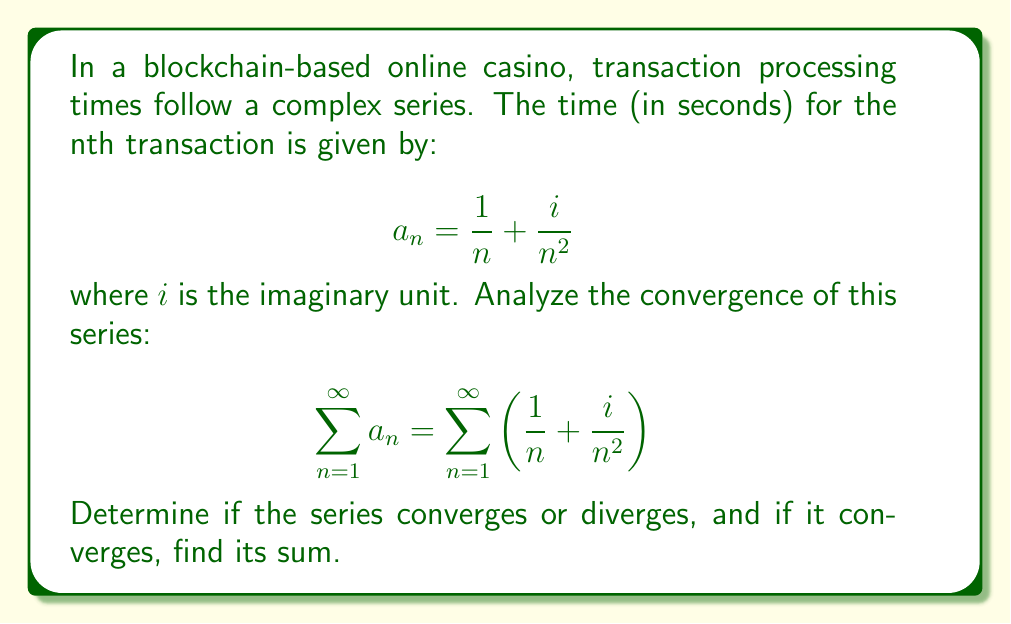Give your solution to this math problem. Let's approach this step-by-step:

1) First, we can split the series into two parts:

   $$\sum_{n=1}^{\infty} \left(\frac{1}{n} + \frac{i}{n^2}\right) = \sum_{n=1}^{\infty} \frac{1}{n} + i\sum_{n=1}^{\infty} \frac{1}{n^2}$$

2) Now we can analyze each part separately:

   a) $\sum_{n=1}^{\infty} \frac{1}{n}$ is the harmonic series, which is known to diverge.

   b) $\sum_{n=1}^{\infty} \frac{1}{n^2}$ is the p-series with p=2, which converges to $\frac{\pi^2}{6}$.

3) For a complex series $\sum (a_n + ib_n)$ to converge, both $\sum a_n$ and $\sum b_n$ must converge.

4) In our case, the real part (the harmonic series) diverges, while the imaginary part converges.

5) Since one part of the series diverges, the entire series diverges.

6) Even though the series diverges, we can still find the partial sum up to N terms:

   $$S_N = \sum_{n=1}^{N} \frac{1}{n} + i\sum_{n=1}^{N} \frac{1}{n^2}$$

   As $N \to \infty$, the real part grows without bound, while the imaginary part approaches $\frac{\pi^2}{6}i$.
Answer: The series diverges. 